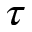<formula> <loc_0><loc_0><loc_500><loc_500>\tau</formula> 